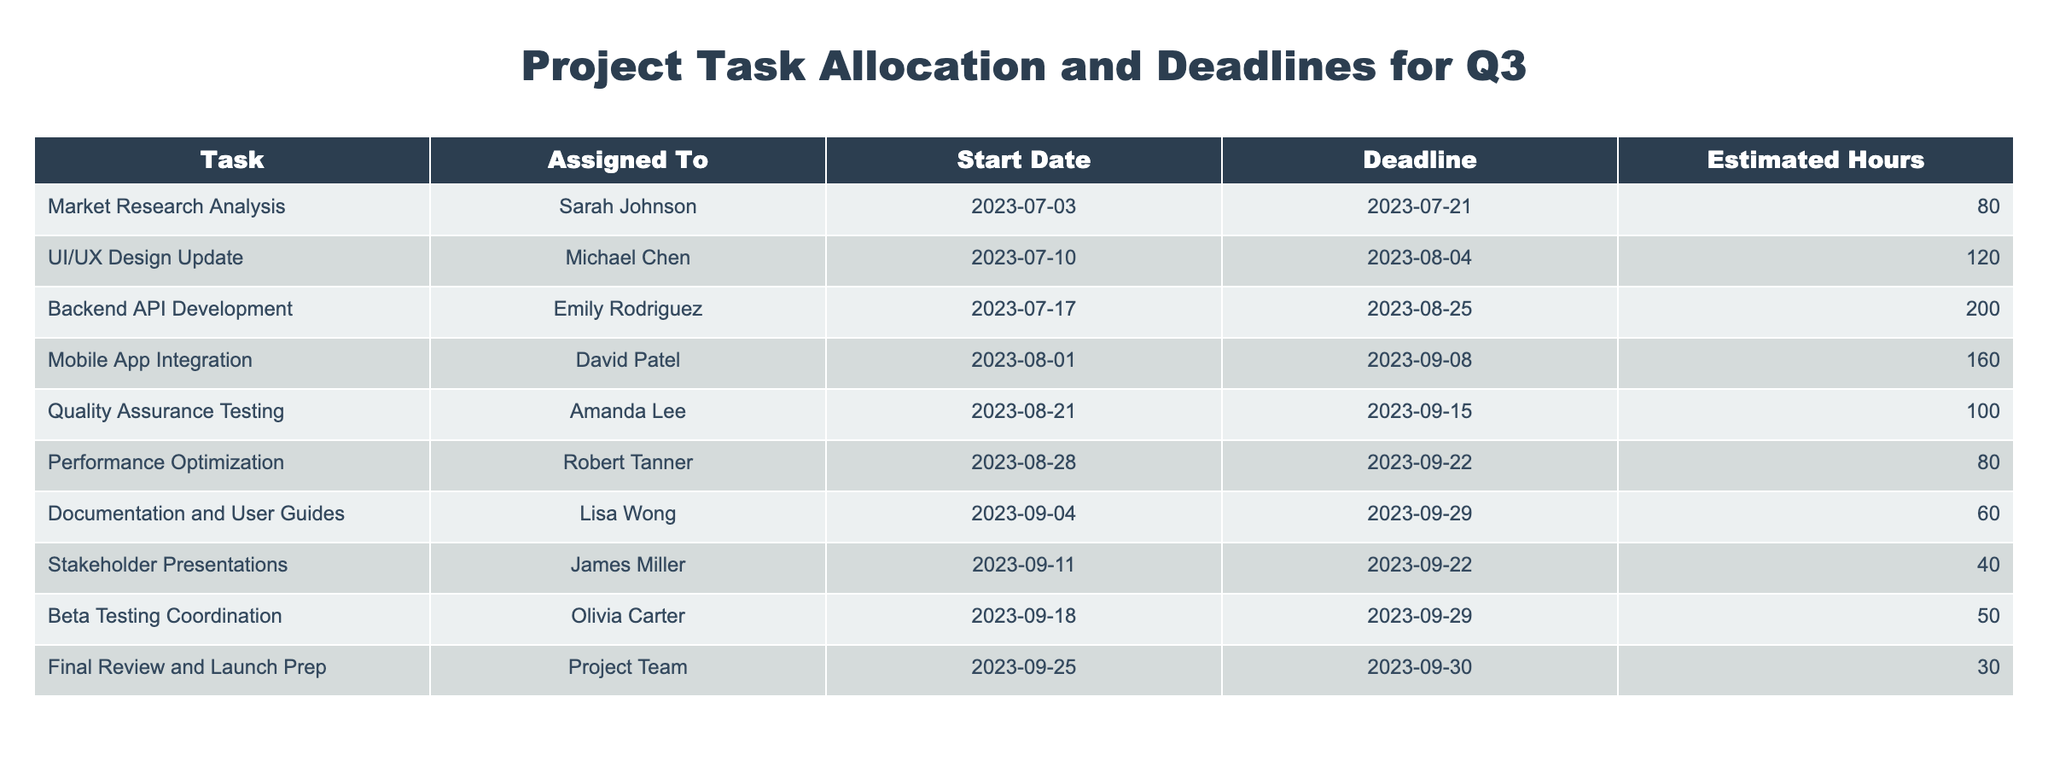What is the deadline for the Backend API Development task? The deadline for the Backend API Development task is directly listed in the table under the "Deadline" column corresponding to that task. It shows the date as 2023-08-25.
Answer: 2023-08-25 Who is assigned to the Quality Assurance Testing task? The table indicates that the Quality Assurance Testing task is assigned to Amanda Lee, as shown under the "Assigned To" column.
Answer: Amanda Lee What is the total estimated hours for tasks assigned to David Patel and Emily Rodriguez? To find the total estimated hours, we look up the estimated hours for tasks assigned to David Patel (Mobile App Integration, 160 hours) and Emily Rodriguez (Backend API Development, 200 hours). Adding them gives 160 + 200 = 360 hours.
Answer: 360 Is there a task assigned to Lisa Wong? Checking the table reveals that Lisa Wong is assigned to the Documentation and User Guides task, confirming that there is indeed a task assigned to her.
Answer: Yes What is the average estimated hours for tasks assigned to the Project Team and Amanda Lee? The estimated hours for the tasks assigned to the Project Team (Final Review and Launch Prep, 30 hours) and Amanda Lee (Quality Assurance Testing, 100 hours) are 30 and 100, respectively. To find the average, we sum the hours (30 + 100 = 130) and divide by the number of tasks (2), resulting in an average of 130 / 2 = 65 hours.
Answer: 65 Which task has the latest deadline, and who is it assigned to? Scanning through the deadlines listed in the table, the task Mobile App Integration has the latest deadline of 2023-09-08. It is assigned to David Patel.
Answer: Mobile App Integration, David Patel How many tasks are due on or before September 22, 2023? By reviewing the deadlines in the table, the tasks due on or before September 22, 2023, are Quality Assurance Testing, Performance Optimization, Stakeholder Presentations, Beta Testing Coordination, and Final Review and Launch Prep. This gives a total of 5 tasks.
Answer: 5 If the UI/UX Design Update task is canceled, how many total hours would remain for the team? The UI/UX Design Update task is assigned to Michael Chen, and it has an estimated 120 hours. The remaining total hours will be calculated by summing all estimated hours (80 + 120 + 200 + 160 + 100 + 80 + 60 + 40 + 50 + 30 = 920) and then subtracting the hours of the canceled task (920 - 120 = 800).
Answer: 800 